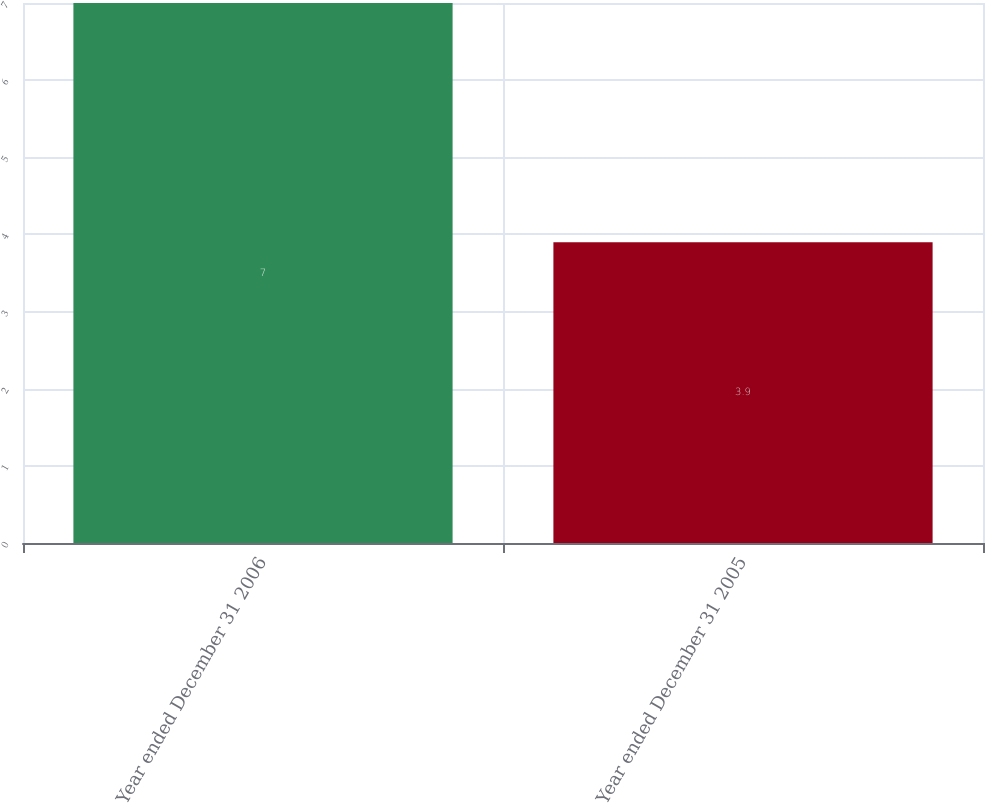Convert chart. <chart><loc_0><loc_0><loc_500><loc_500><bar_chart><fcel>Year ended December 31 2006<fcel>Year ended December 31 2005<nl><fcel>7<fcel>3.9<nl></chart> 